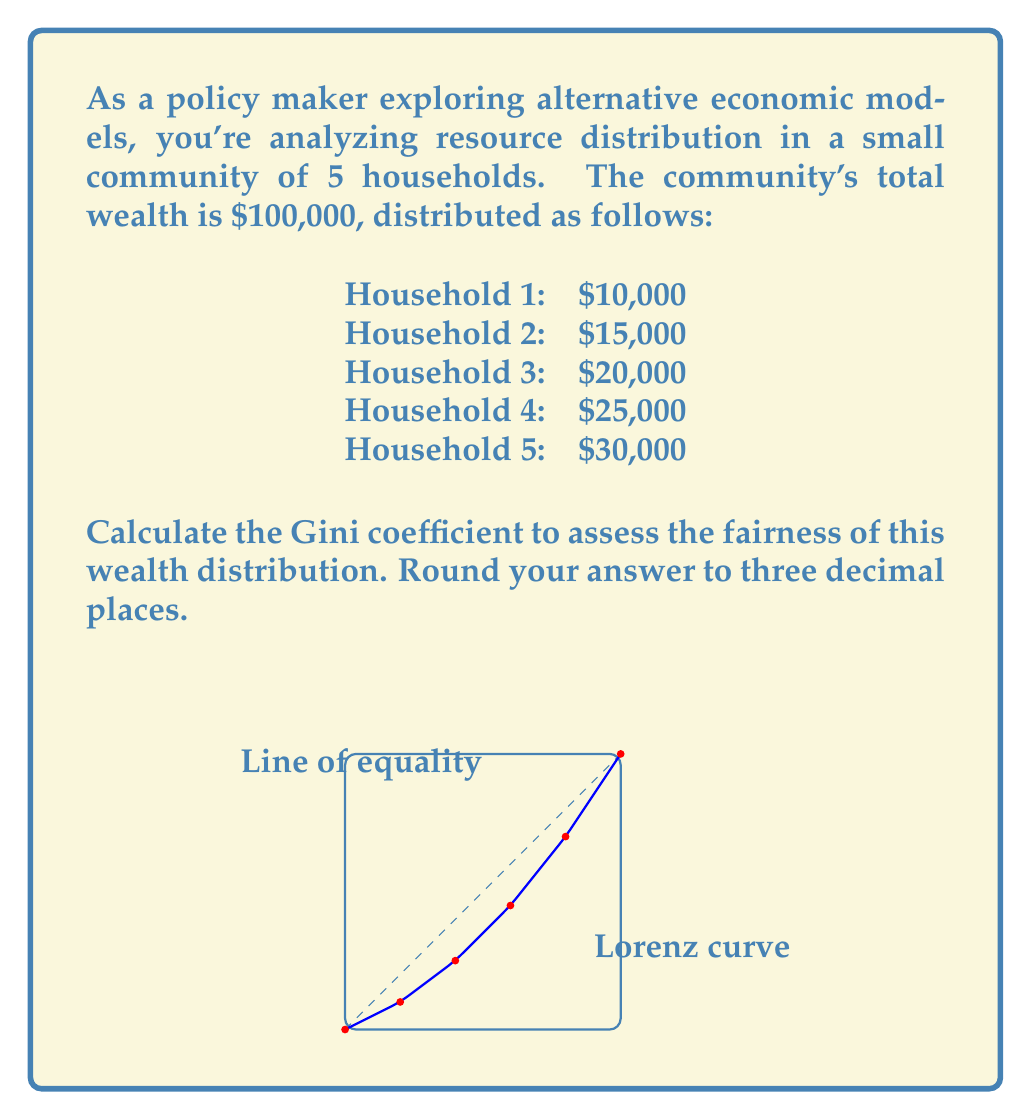What is the answer to this math problem? To calculate the Gini coefficient, we'll follow these steps:

1) First, calculate the area under the line of perfect equality:
   This is always 0.5 (area of a triangle with base 1 and height 1).

2) Calculate the area under the Lorenz curve:
   a) Sort the wealth values in ascending order (already done).
   b) Calculate cumulative percentages of population and wealth:

      Population: 20%, 40%, 60%, 80%, 100%
      Wealth: 10%, 25%, 45%, 70%, 100%

   c) Calculate the area using the trapezoidal rule:
      $$A = \frac{1}{2} \sum_{i=1}^{n} (y_i + y_{i-1}) \cdot \frac{1}{n}$$
      where $y_i$ is the cumulative percentage of wealth for the $i$-th household.

      $$A = \frac{1}{2} \cdot \frac{1}{5} \cdot [(0 + 0.1) + (0.1 + 0.25) + (0.25 + 0.45) + (0.45 + 0.7) + (0.7 + 1)]$$
      $$A = 0.1 \cdot (0.1 + 0.35 + 0.7 + 1.15 + 1.7) = 0.1 \cdot 4 = 0.4$$

3) Calculate the Gini coefficient:
   $$G = \frac{\text{Area between line of equality and Lorenz curve}}{\text{Area under line of equality}}$$
   $$G = \frac{0.5 - 0.4}{0.5} = \frac{0.1}{0.5} = 0.2$$

Therefore, the Gini coefficient is 0.2 or 0.200 when rounded to three decimal places.
Answer: 0.200 